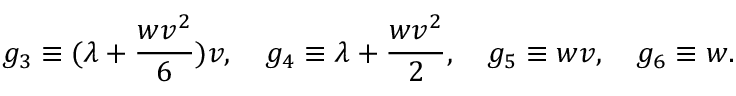<formula> <loc_0><loc_0><loc_500><loc_500>g _ { 3 } \equiv ( \lambda + \frac { w v ^ { 2 } } { 6 } ) v , \quad g _ { 4 } \equiv \lambda + \frac { w v ^ { 2 } } { 2 } , \quad g _ { 5 } \equiv w v , \quad g _ { 6 } \equiv w .</formula> 